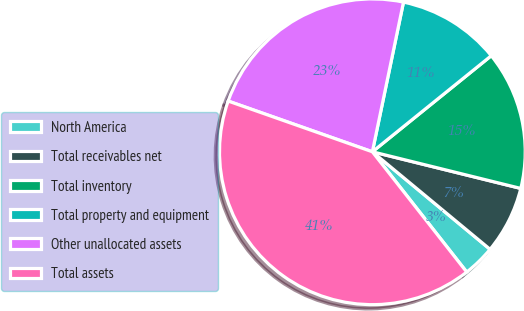<chart> <loc_0><loc_0><loc_500><loc_500><pie_chart><fcel>North America<fcel>Total receivables net<fcel>Total inventory<fcel>Total property and equipment<fcel>Other unallocated assets<fcel>Total assets<nl><fcel>3.4%<fcel>7.16%<fcel>14.67%<fcel>10.92%<fcel>22.88%<fcel>40.97%<nl></chart> 